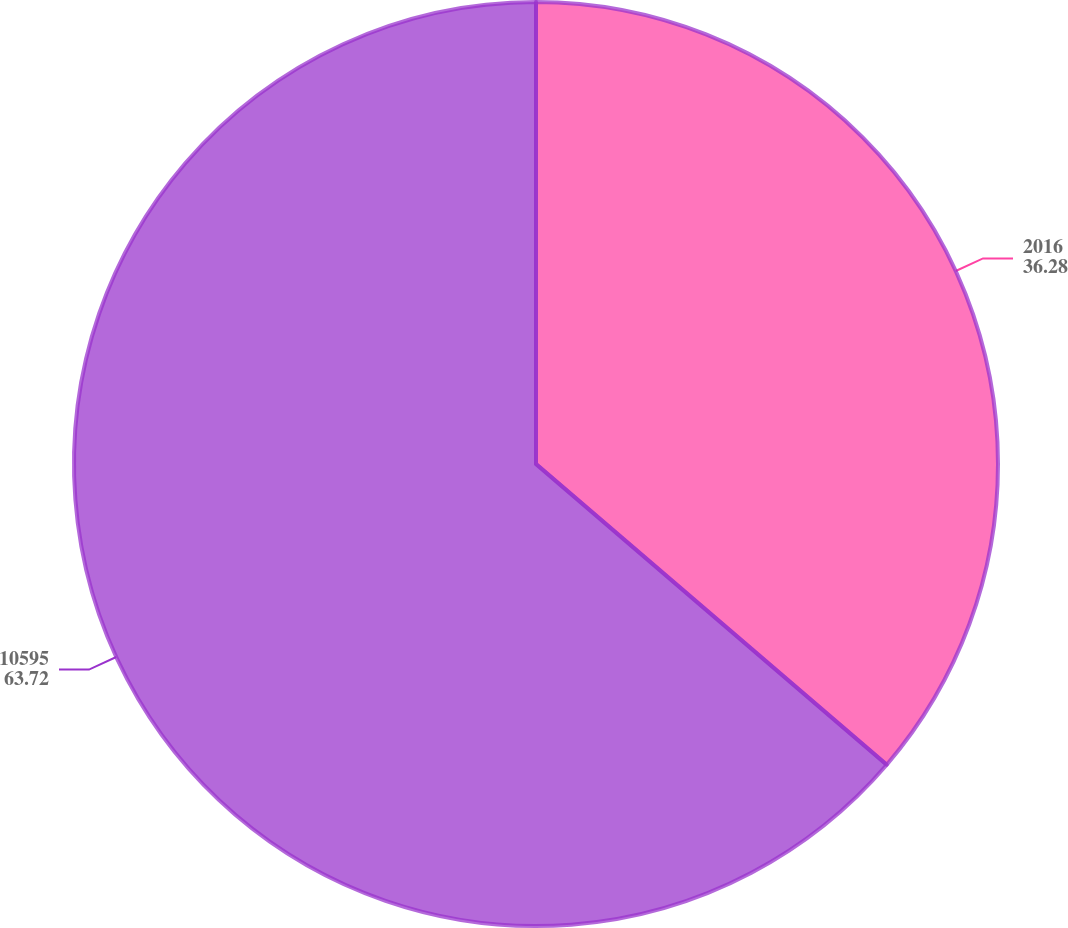Convert chart to OTSL. <chart><loc_0><loc_0><loc_500><loc_500><pie_chart><fcel>2016<fcel>10595<nl><fcel>36.28%<fcel>63.72%<nl></chart> 